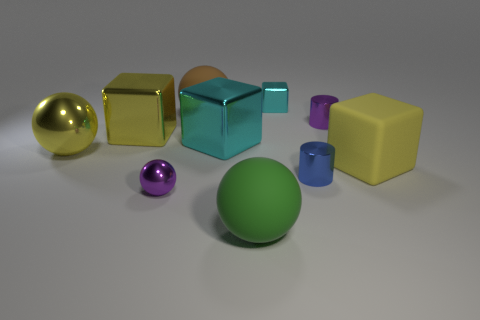Are there any big blue balls made of the same material as the purple cylinder?
Offer a very short reply. No. What material is the other cylinder that is the same size as the purple cylinder?
Your response must be concise. Metal. Is the number of large things that are in front of the tiny purple cylinder less than the number of tiny purple balls that are to the left of the small metal ball?
Make the answer very short. No. There is a small thing that is in front of the rubber block and to the right of the small block; what is its shape?
Your answer should be very brief. Cylinder. What number of large yellow metal objects have the same shape as the large brown rubber object?
Ensure brevity in your answer.  1. There is another cyan cube that is made of the same material as the big cyan block; what size is it?
Ensure brevity in your answer.  Small. Is the number of red rubber objects greater than the number of objects?
Ensure brevity in your answer.  No. The large shiny object that is left of the yellow metal cube is what color?
Provide a short and direct response. Yellow. What is the size of the cube that is both on the right side of the brown matte ball and to the left of the green ball?
Provide a succinct answer. Large. What number of other rubber blocks are the same size as the yellow rubber block?
Provide a short and direct response. 0. 